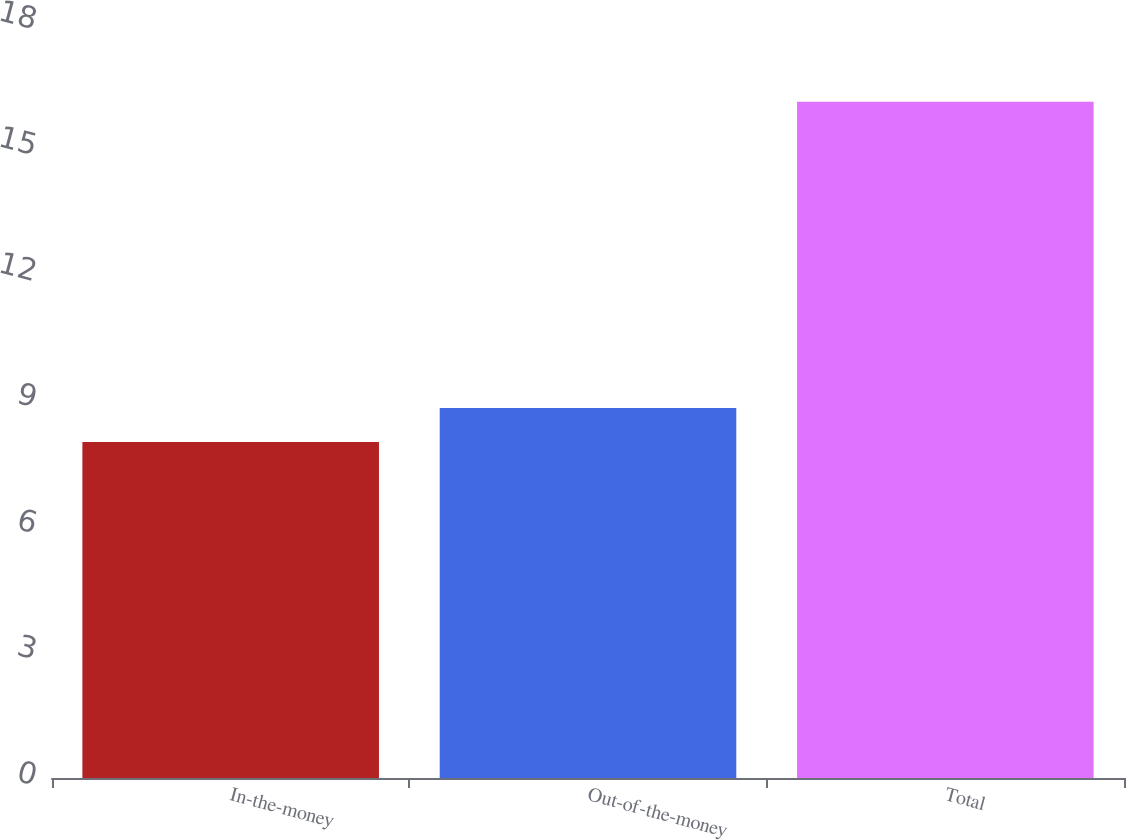Convert chart. <chart><loc_0><loc_0><loc_500><loc_500><bar_chart><fcel>In-the-money<fcel>Out-of-the-money<fcel>Total<nl><fcel>8<fcel>8.81<fcel>16.1<nl></chart> 